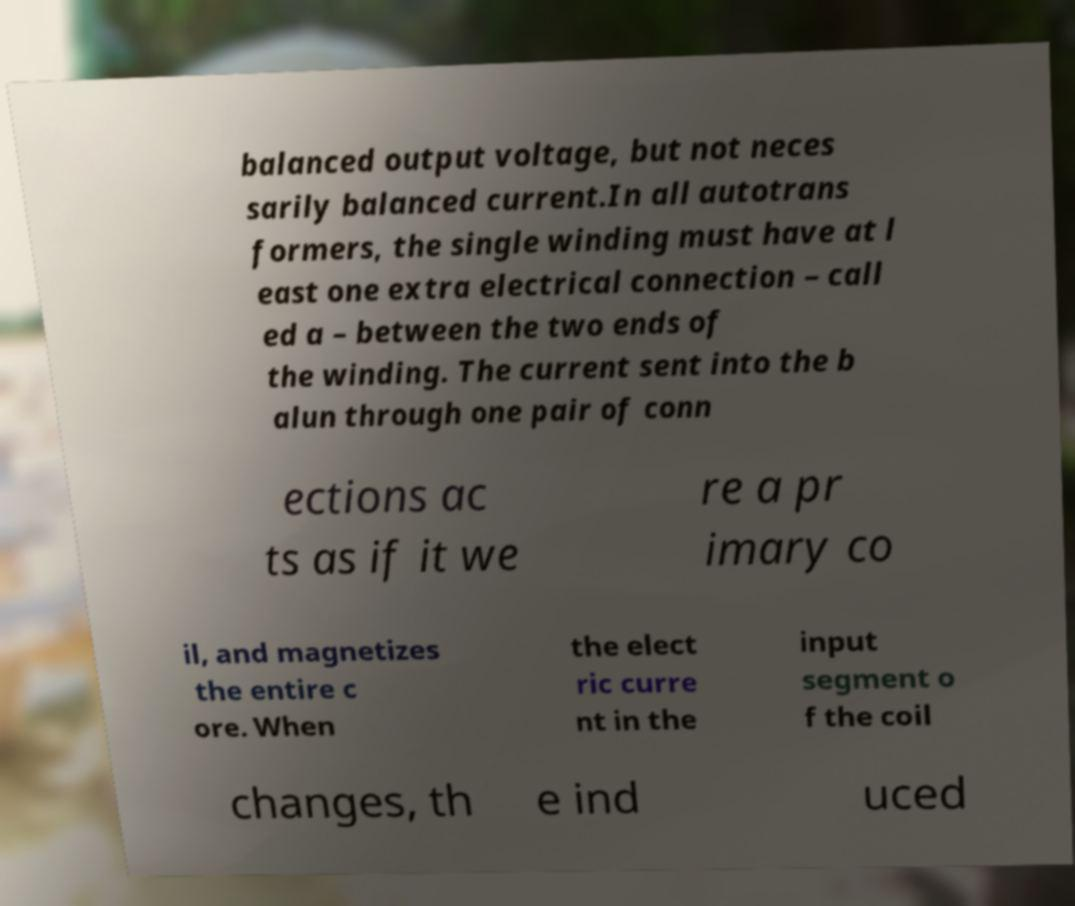For documentation purposes, I need the text within this image transcribed. Could you provide that? balanced output voltage, but not neces sarily balanced current.In all autotrans formers, the single winding must have at l east one extra electrical connection – call ed a – between the two ends of the winding. The current sent into the b alun through one pair of conn ections ac ts as if it we re a pr imary co il, and magnetizes the entire c ore. When the elect ric curre nt in the input segment o f the coil changes, th e ind uced 